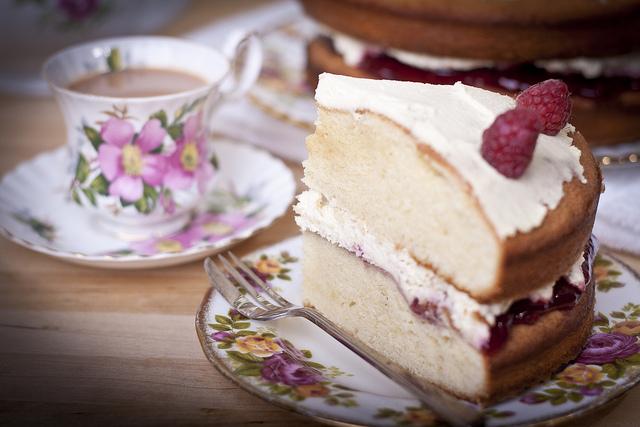What sits atop the slice?
Keep it brief. Raspberry. Is the cup full?
Quick response, please. Yes. The designs on the plates are?
Write a very short answer. Flowers. 